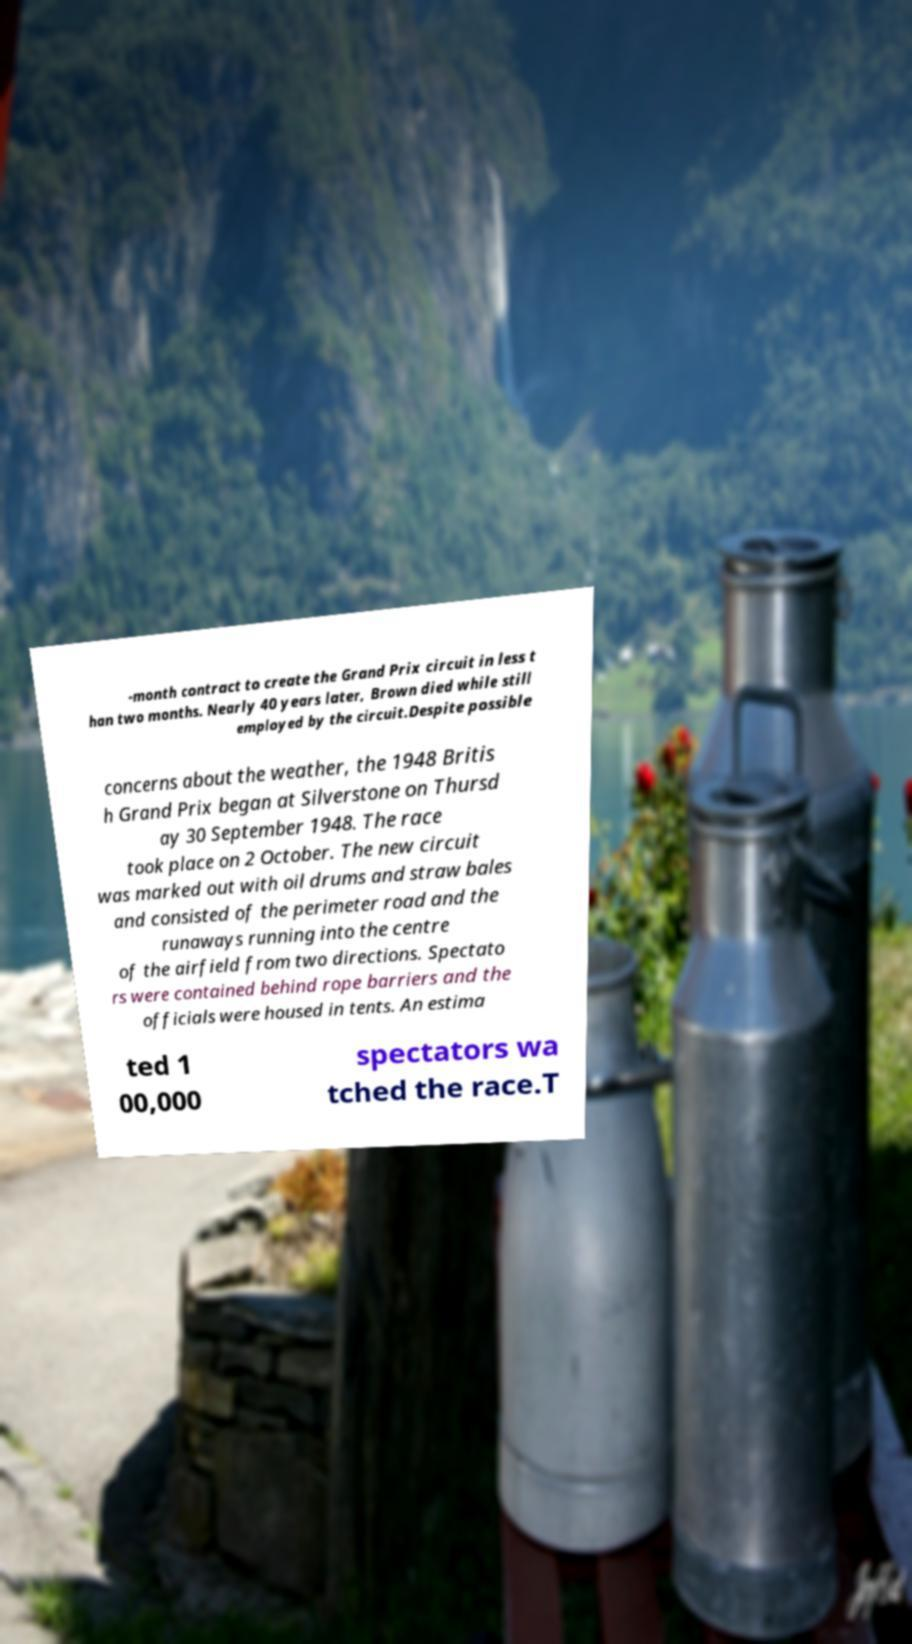Could you extract and type out the text from this image? -month contract to create the Grand Prix circuit in less t han two months. Nearly 40 years later, Brown died while still employed by the circuit.Despite possible concerns about the weather, the 1948 Britis h Grand Prix began at Silverstone on Thursd ay 30 September 1948. The race took place on 2 October. The new circuit was marked out with oil drums and straw bales and consisted of the perimeter road and the runaways running into the centre of the airfield from two directions. Spectato rs were contained behind rope barriers and the officials were housed in tents. An estima ted 1 00,000 spectators wa tched the race.T 